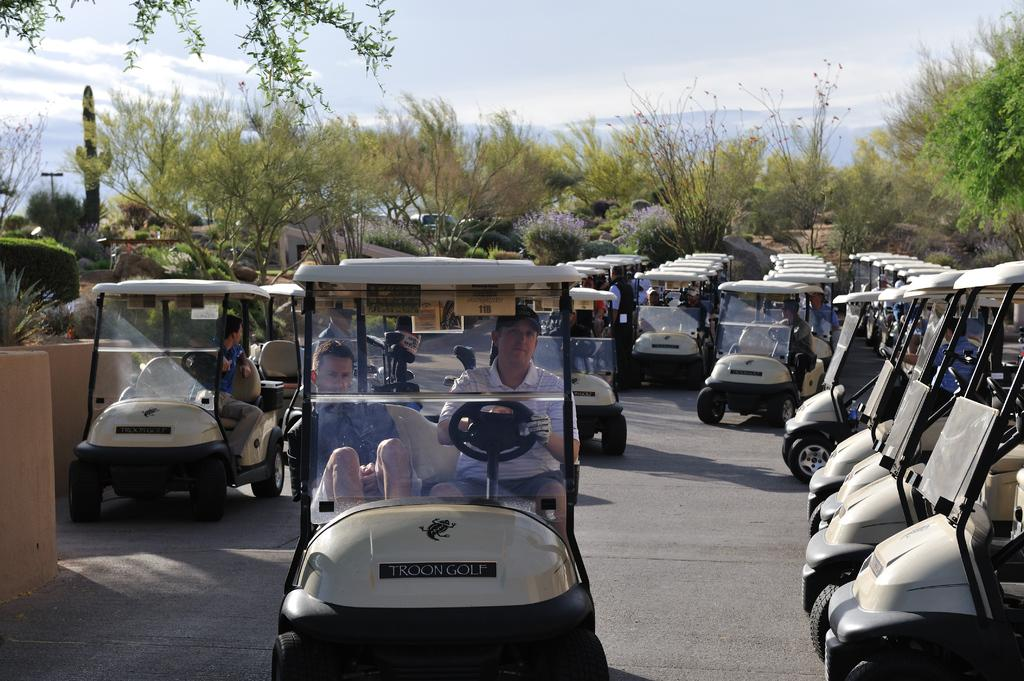What are the persons in the image doing? The persons in the image are sitting in vehicles. What can be seen in the background of the image? There are trees and other objects in the background of the image. How many legs can be seen in the image? There is no information about legs in the image, as it features persons sitting in vehicles and objects in the background. 